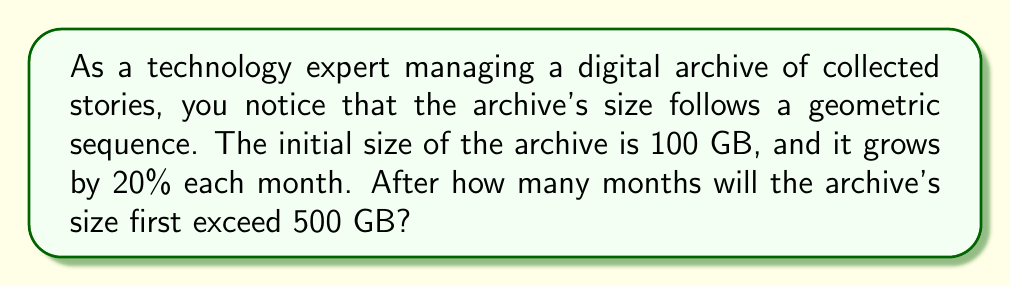Teach me how to tackle this problem. Let's approach this step-by-step:

1) In a geometric sequence, each term is a constant multiple of the previous term. Here, the constant is 1.20 (120% of the previous term).

2) We can represent the size of the archive after $n$ months as:

   $$ S_n = 100 \cdot (1.20)^n $$

   where $S_n$ is the size in GB after $n$ months.

3) We want to find the smallest $n$ for which $S_n > 500$. In mathematical terms:

   $$ 100 \cdot (1.20)^n > 500 $$

4) Dividing both sides by 100:

   $$ (1.20)^n > 5 $$

5) Taking the logarithm of both sides:

   $$ n \cdot \log(1.20) > \log(5) $$

6) Solving for $n$:

   $$ n > \frac{\log(5)}{\log(1.20)} $$

7) Using a calculator or computer:

   $$ n > \frac{0.69897}{0.07918} \approx 8.8259 $$

8) Since $n$ must be a whole number of months, we round up to the next integer.
Answer: The archive's size will first exceed 500 GB after 9 months. 